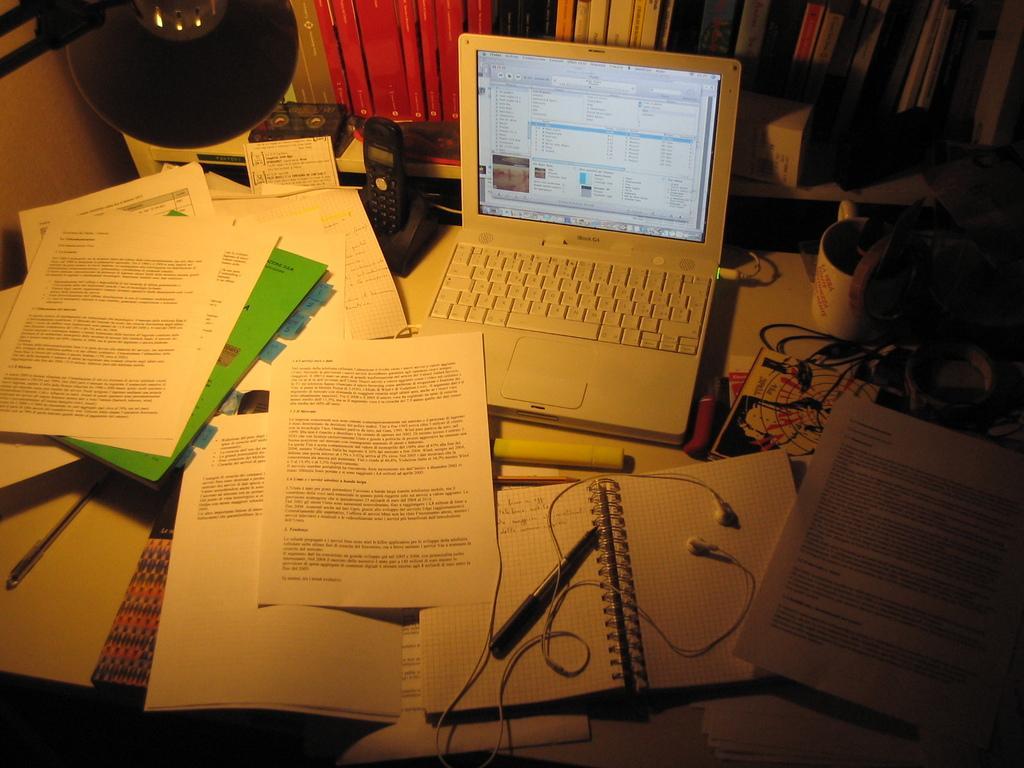Please provide a concise description of this image. There are papers, wires, laptop and other items in the foreground area of the image, it seems like a lamp at the top side and books in the background. 